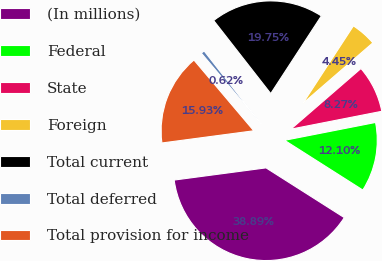<chart> <loc_0><loc_0><loc_500><loc_500><pie_chart><fcel>(In millions)<fcel>Federal<fcel>State<fcel>Foreign<fcel>Total current<fcel>Total deferred<fcel>Total provision for income<nl><fcel>38.89%<fcel>12.1%<fcel>8.27%<fcel>4.45%<fcel>19.75%<fcel>0.62%<fcel>15.93%<nl></chart> 